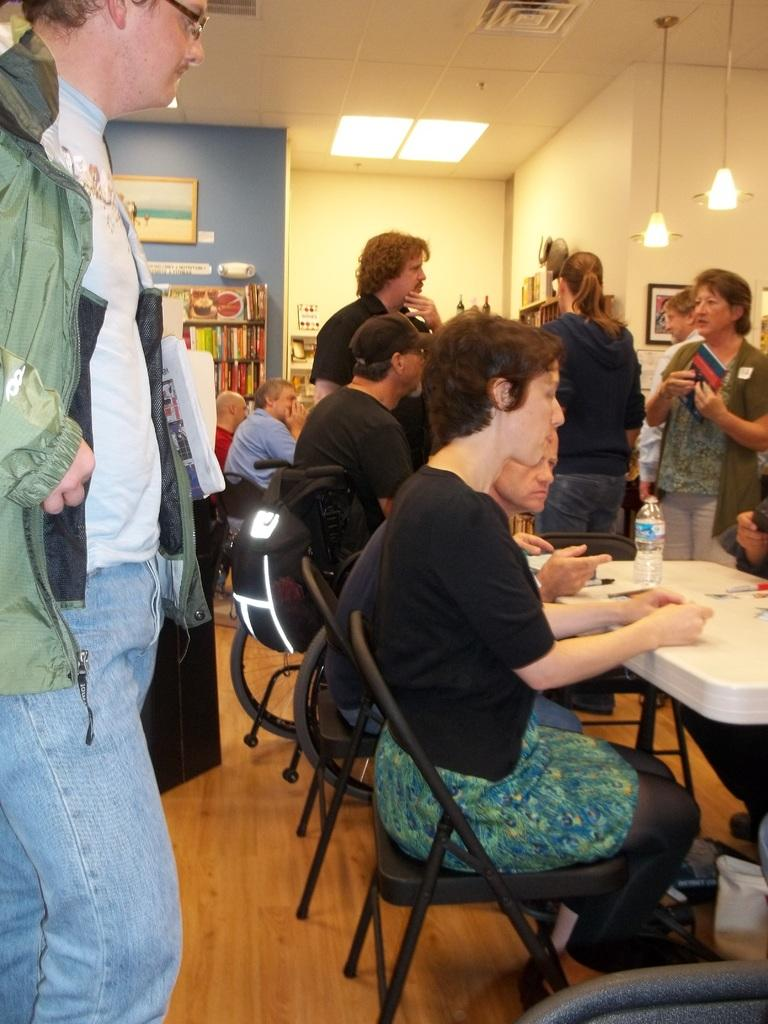How many people are in the image? There is a group of people in the image. What are some of the people doing in the image? Some people are sitting on chairs, while others are standing on the floor. Where are the chairs located in relation to the table? The chairs are in front of a table. Can you tell me how many people are playing on the playground in the image? There is no playground present in the image, so it's not possible to determine how many people might be playing on it. 